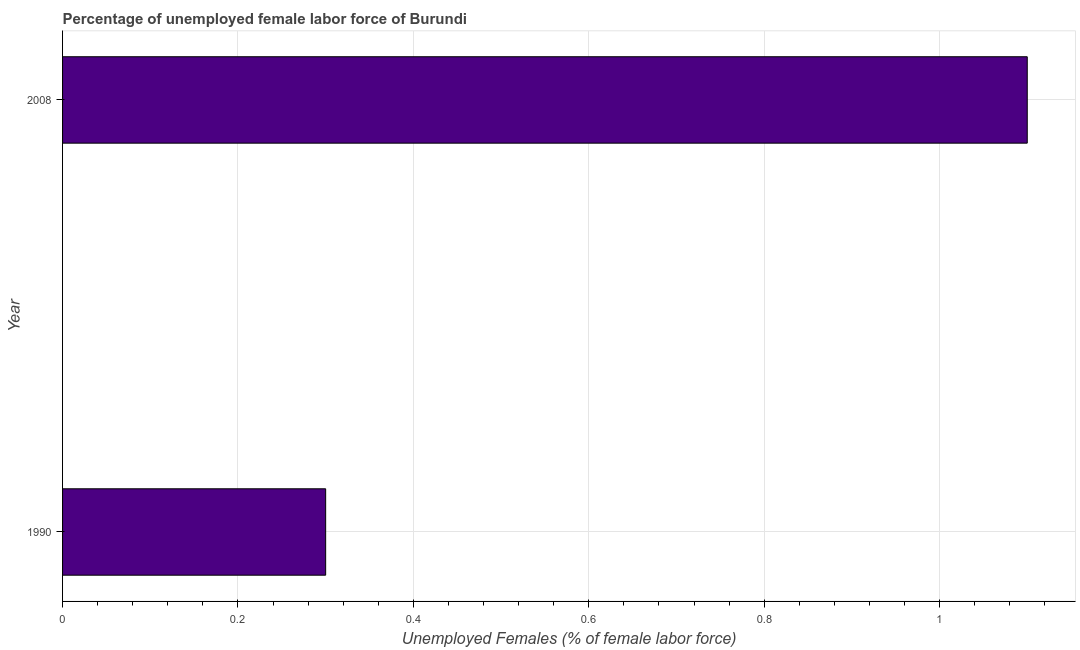What is the title of the graph?
Your answer should be compact. Percentage of unemployed female labor force of Burundi. What is the label or title of the X-axis?
Offer a terse response. Unemployed Females (% of female labor force). What is the total unemployed female labour force in 2008?
Keep it short and to the point. 1.1. Across all years, what is the maximum total unemployed female labour force?
Your answer should be very brief. 1.1. Across all years, what is the minimum total unemployed female labour force?
Offer a terse response. 0.3. What is the sum of the total unemployed female labour force?
Your answer should be very brief. 1.4. What is the median total unemployed female labour force?
Offer a terse response. 0.7. In how many years, is the total unemployed female labour force greater than 0.48 %?
Offer a very short reply. 1. What is the ratio of the total unemployed female labour force in 1990 to that in 2008?
Your answer should be very brief. 0.27. Is the total unemployed female labour force in 1990 less than that in 2008?
Provide a short and direct response. Yes. How many bars are there?
Give a very brief answer. 2. How many years are there in the graph?
Ensure brevity in your answer.  2. Are the values on the major ticks of X-axis written in scientific E-notation?
Your answer should be compact. No. What is the Unemployed Females (% of female labor force) of 1990?
Keep it short and to the point. 0.3. What is the Unemployed Females (% of female labor force) of 2008?
Provide a succinct answer. 1.1. What is the difference between the Unemployed Females (% of female labor force) in 1990 and 2008?
Keep it short and to the point. -0.8. What is the ratio of the Unemployed Females (% of female labor force) in 1990 to that in 2008?
Ensure brevity in your answer.  0.27. 